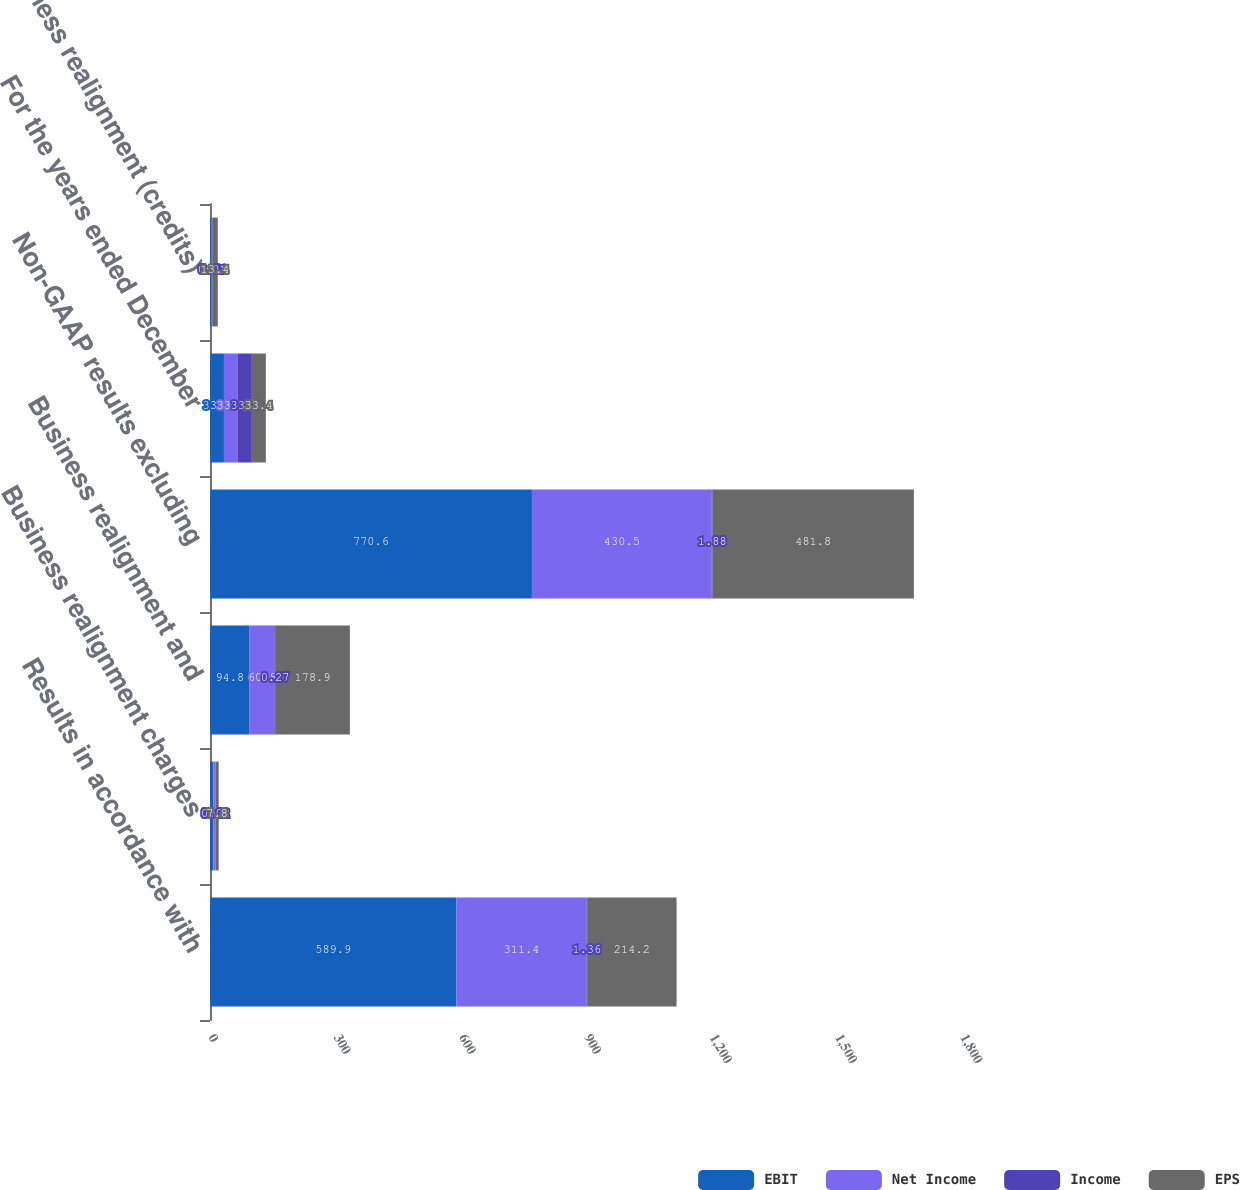Convert chart to OTSL. <chart><loc_0><loc_0><loc_500><loc_500><stacked_bar_chart><ecel><fcel>Results in accordance with<fcel>Business realignment charges<fcel>Business realignment and<fcel>Non-GAAP results excluding<fcel>For the years ended December<fcel>Business realignment (credits)<nl><fcel>EBIT<fcel>589.9<fcel>8.1<fcel>94.8<fcel>770.6<fcel>33.4<fcel>3.2<nl><fcel>Net Income<fcel>311.4<fcel>4.9<fcel>60.8<fcel>430.5<fcel>33.4<fcel>2<nl><fcel>Income<fcel>1.36<fcel>0.02<fcel>0.27<fcel>1.88<fcel>33.4<fcel>0.01<nl><fcel>EPS<fcel>214.2<fcel>7.8<fcel>178.9<fcel>481.8<fcel>33.4<fcel>13.4<nl></chart> 